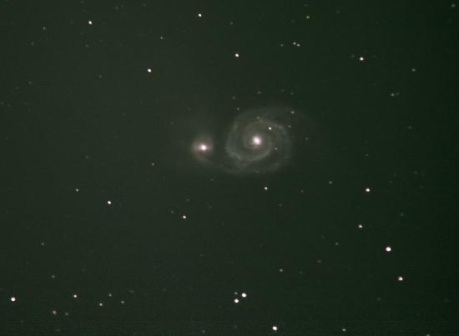What does the presence of this galaxy in the image tell us about the universe? The presence of the galaxy in this image serves as a profound reminder of the universe's vastness and complexity. Not only does the galaxy indicate the large scales of distance and size within the cosmos, but it also hints at the myriad processes occurring within—such as stellar evolution, galactic formation, and the dynamics of gravity shaping the spiral arms. It underscores how galaxies are building blocks of the universe, with each one containing a wealth of stars, planets, and possibly even life. This kind of image fuels our curiosity and drives scientific exploration as we seek to understand our place in the grand cosmic tapestry. 